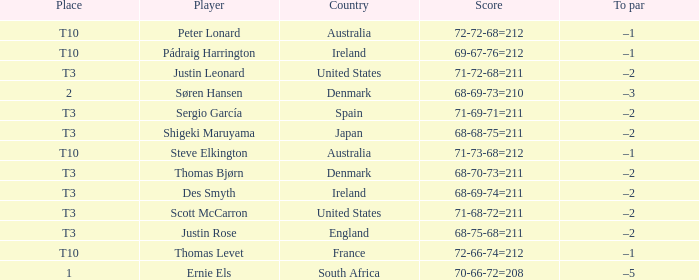What was Australia's score when Peter Lonard played? 72-72-68=212. 